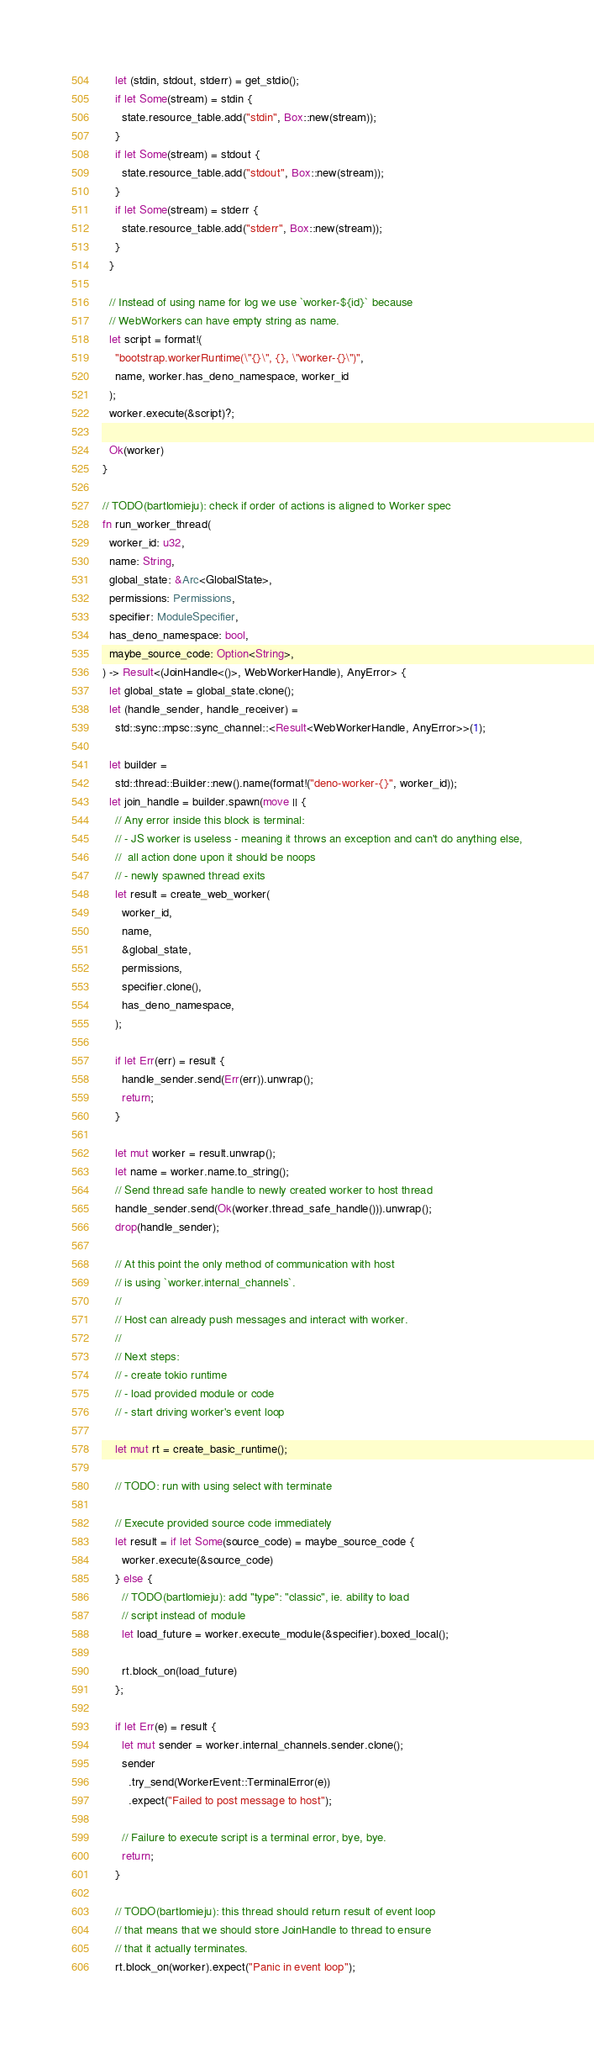Convert code to text. <code><loc_0><loc_0><loc_500><loc_500><_Rust_>    let (stdin, stdout, stderr) = get_stdio();
    if let Some(stream) = stdin {
      state.resource_table.add("stdin", Box::new(stream));
    }
    if let Some(stream) = stdout {
      state.resource_table.add("stdout", Box::new(stream));
    }
    if let Some(stream) = stderr {
      state.resource_table.add("stderr", Box::new(stream));
    }
  }

  // Instead of using name for log we use `worker-${id}` because
  // WebWorkers can have empty string as name.
  let script = format!(
    "bootstrap.workerRuntime(\"{}\", {}, \"worker-{}\")",
    name, worker.has_deno_namespace, worker_id
  );
  worker.execute(&script)?;

  Ok(worker)
}

// TODO(bartlomieju): check if order of actions is aligned to Worker spec
fn run_worker_thread(
  worker_id: u32,
  name: String,
  global_state: &Arc<GlobalState>,
  permissions: Permissions,
  specifier: ModuleSpecifier,
  has_deno_namespace: bool,
  maybe_source_code: Option<String>,
) -> Result<(JoinHandle<()>, WebWorkerHandle), AnyError> {
  let global_state = global_state.clone();
  let (handle_sender, handle_receiver) =
    std::sync::mpsc::sync_channel::<Result<WebWorkerHandle, AnyError>>(1);

  let builder =
    std::thread::Builder::new().name(format!("deno-worker-{}", worker_id));
  let join_handle = builder.spawn(move || {
    // Any error inside this block is terminal:
    // - JS worker is useless - meaning it throws an exception and can't do anything else,
    //  all action done upon it should be noops
    // - newly spawned thread exits
    let result = create_web_worker(
      worker_id,
      name,
      &global_state,
      permissions,
      specifier.clone(),
      has_deno_namespace,
    );

    if let Err(err) = result {
      handle_sender.send(Err(err)).unwrap();
      return;
    }

    let mut worker = result.unwrap();
    let name = worker.name.to_string();
    // Send thread safe handle to newly created worker to host thread
    handle_sender.send(Ok(worker.thread_safe_handle())).unwrap();
    drop(handle_sender);

    // At this point the only method of communication with host
    // is using `worker.internal_channels`.
    //
    // Host can already push messages and interact with worker.
    //
    // Next steps:
    // - create tokio runtime
    // - load provided module or code
    // - start driving worker's event loop

    let mut rt = create_basic_runtime();

    // TODO: run with using select with terminate

    // Execute provided source code immediately
    let result = if let Some(source_code) = maybe_source_code {
      worker.execute(&source_code)
    } else {
      // TODO(bartlomieju): add "type": "classic", ie. ability to load
      // script instead of module
      let load_future = worker.execute_module(&specifier).boxed_local();

      rt.block_on(load_future)
    };

    if let Err(e) = result {
      let mut sender = worker.internal_channels.sender.clone();
      sender
        .try_send(WorkerEvent::TerminalError(e))
        .expect("Failed to post message to host");

      // Failure to execute script is a terminal error, bye, bye.
      return;
    }

    // TODO(bartlomieju): this thread should return result of event loop
    // that means that we should store JoinHandle to thread to ensure
    // that it actually terminates.
    rt.block_on(worker).expect("Panic in event loop");</code> 